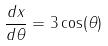Convert formula to latex. <formula><loc_0><loc_0><loc_500><loc_500>\frac { d x } { d \theta } = 3 \cos ( \theta )</formula> 